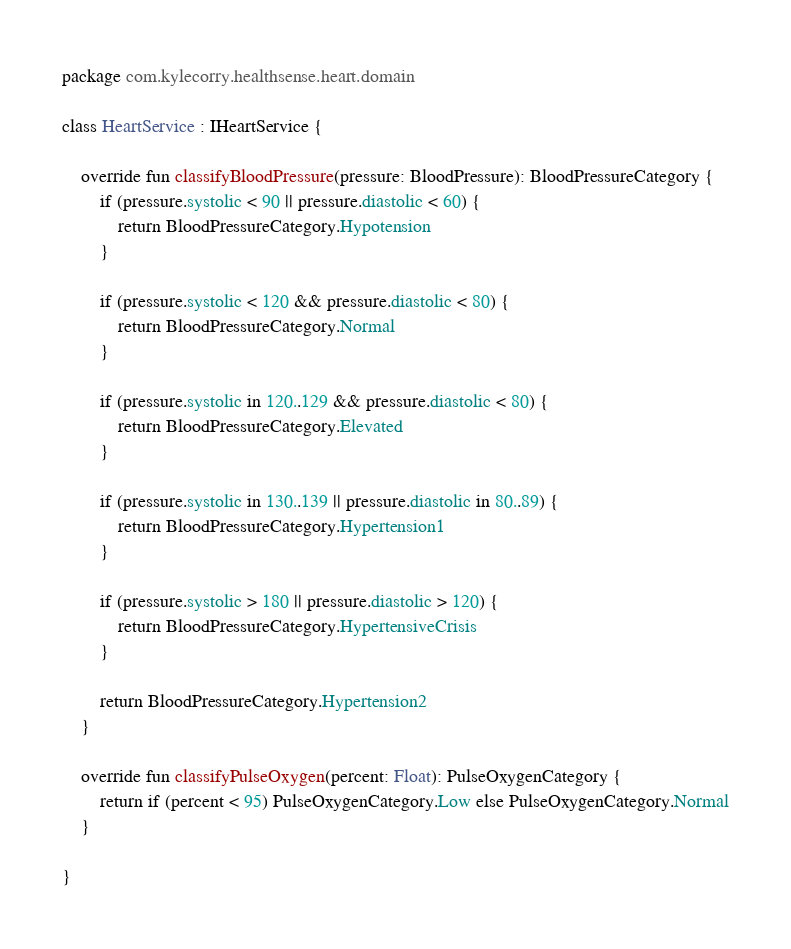<code> <loc_0><loc_0><loc_500><loc_500><_Kotlin_>package com.kylecorry.healthsense.heart.domain

class HeartService : IHeartService {

    override fun classifyBloodPressure(pressure: BloodPressure): BloodPressureCategory {
        if (pressure.systolic < 90 || pressure.diastolic < 60) {
            return BloodPressureCategory.Hypotension
        }

        if (pressure.systolic < 120 && pressure.diastolic < 80) {
            return BloodPressureCategory.Normal
        }

        if (pressure.systolic in 120..129 && pressure.diastolic < 80) {
            return BloodPressureCategory.Elevated
        }

        if (pressure.systolic in 130..139 || pressure.diastolic in 80..89) {
            return BloodPressureCategory.Hypertension1
        }

        if (pressure.systolic > 180 || pressure.diastolic > 120) {
            return BloodPressureCategory.HypertensiveCrisis
        }

        return BloodPressureCategory.Hypertension2
    }

    override fun classifyPulseOxygen(percent: Float): PulseOxygenCategory {
        return if (percent < 95) PulseOxygenCategory.Low else PulseOxygenCategory.Normal
    }

}</code> 